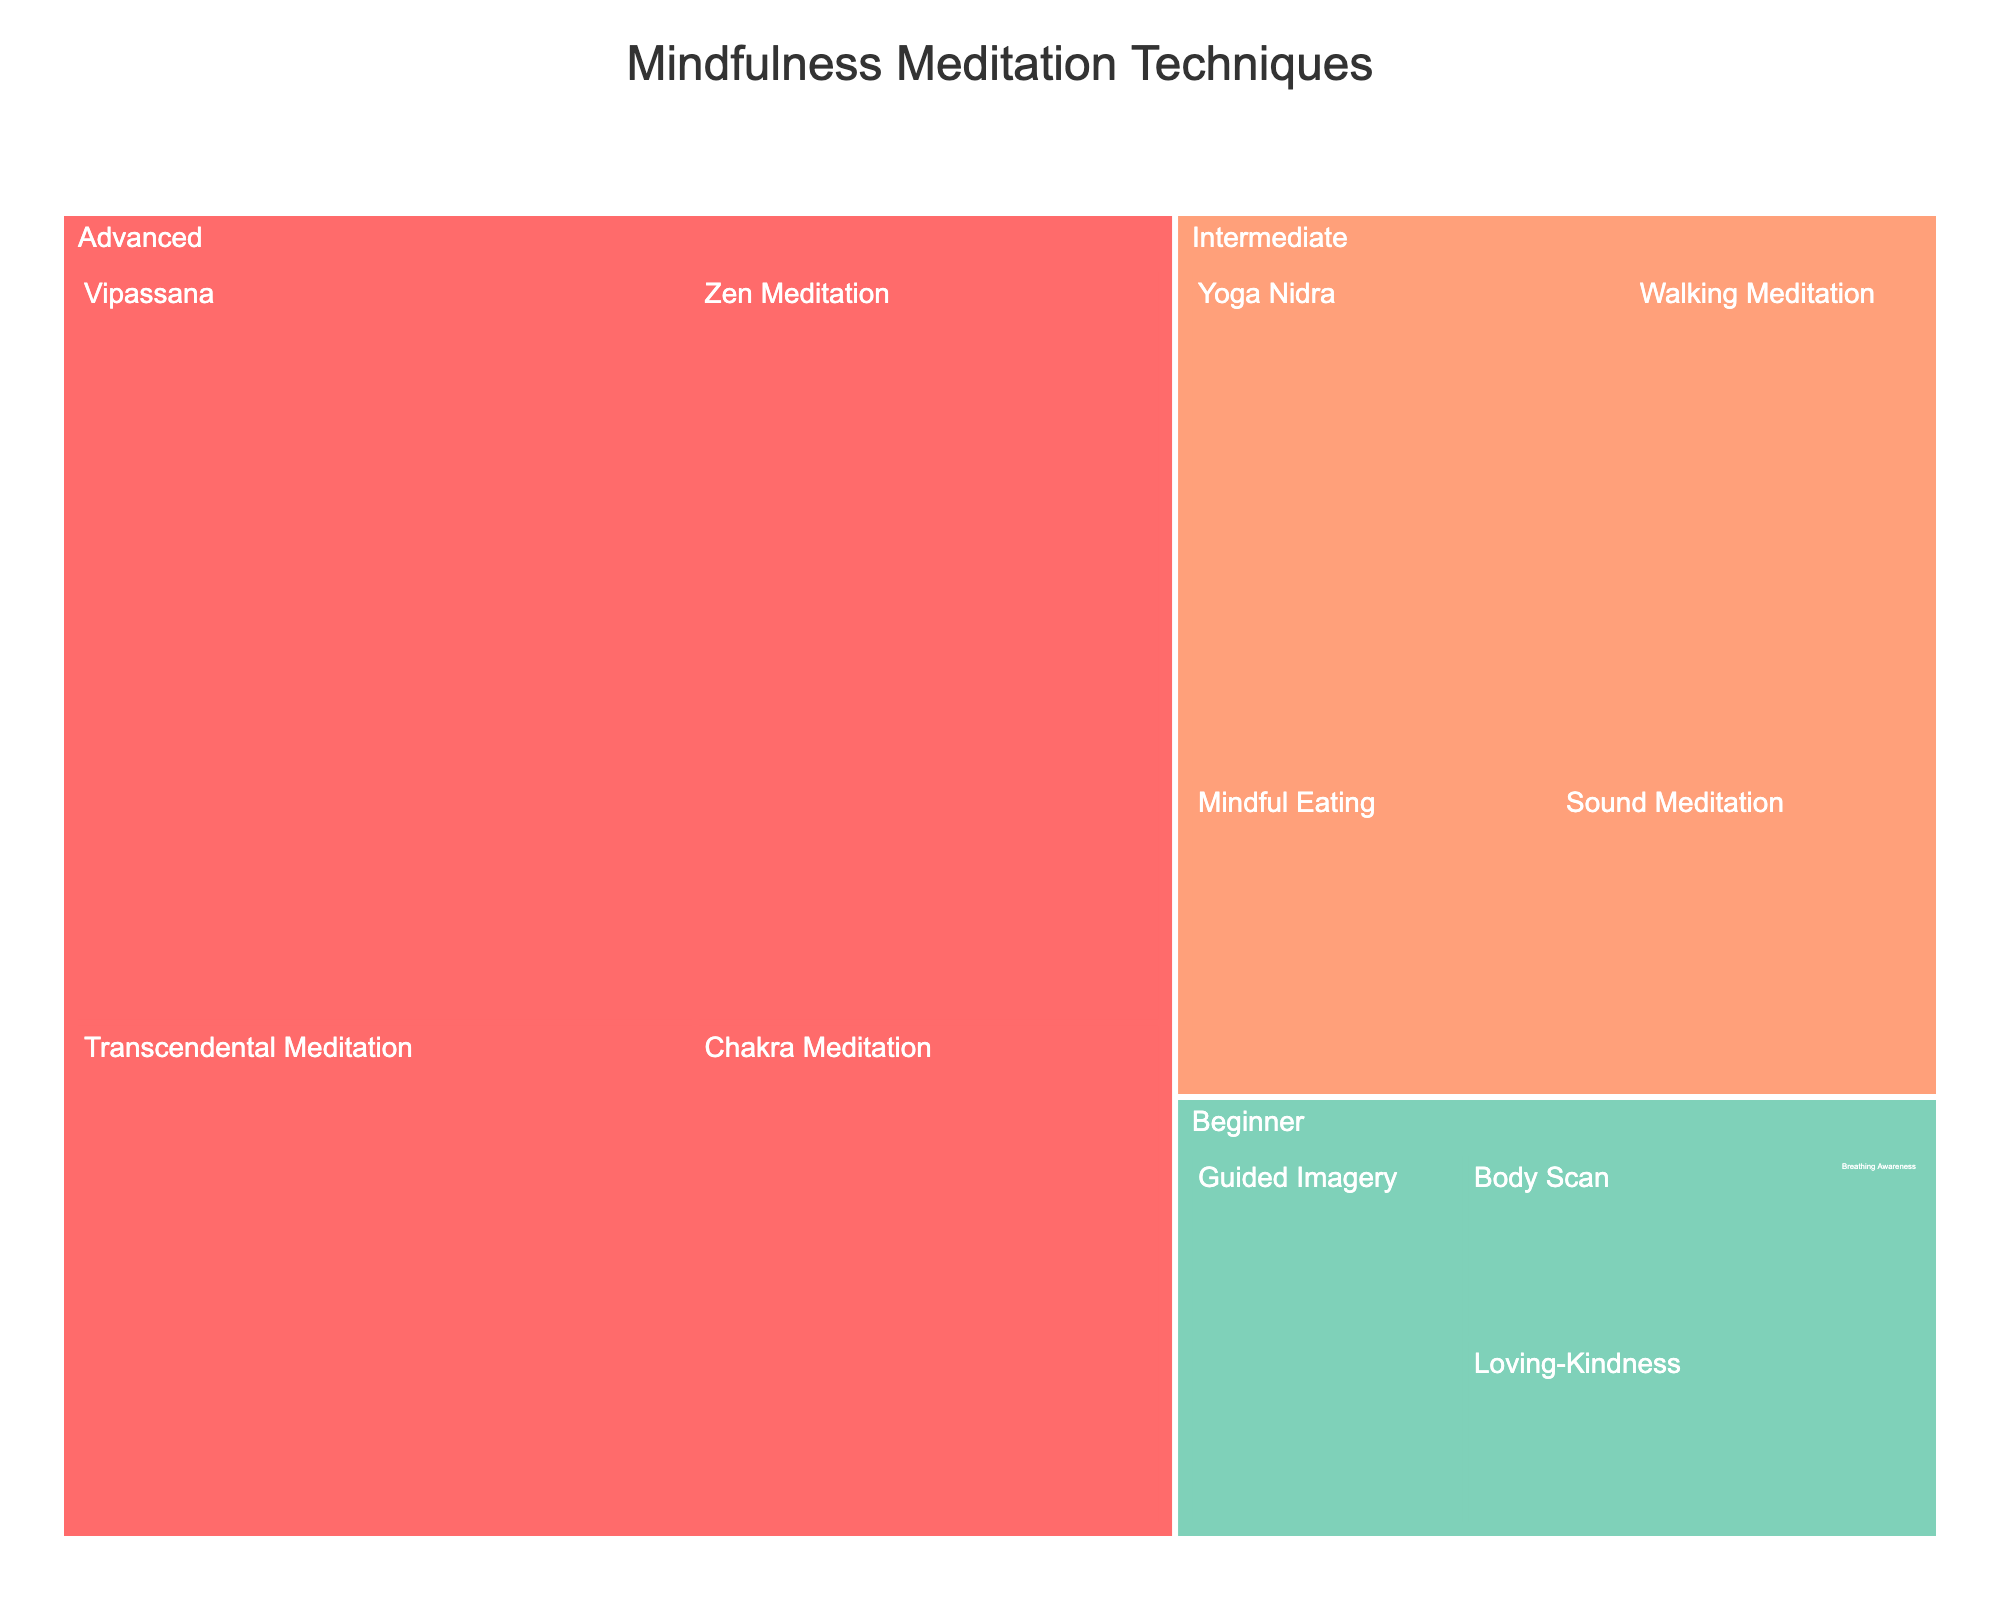What is the title of the figure? The title is displayed at the top of the treemap.
Answer: Mindfulness Meditation Techniques Which technique is the easiest and has the least time commitment? Look for techniques labeled 'Easy' with the smallest time value.
Answer: Breathing Awareness What is the total time commitment for beginner techniques? Sum the time values of all beginner techniques. 10 + 5 + 10 + 15 = 40
Answer: 40 minutes Which advanced technique requires the most time? Identify the advanced technique with the highest time value.
Answer: Vipassana How does the time commitment of “Intermediate” category compare to the “Beginner” category? Sum the time values of both categories and compare. Intermediate: 20 + 15 + 15 + 30 = 80; Beginner: 10 + 5 + 10 + 15 = 40
Answer: Intermediate techniques require more time What's the average time commitment for advanced techniques? Sum the time values and divide by the number of advanced techniques. (60 + 45 + 40 + 30) / 4 = 43.75
Answer: 43.75 minutes Which technique in the “Intermediate” category has the shortest time commitment? Look for the intermediate technique with the smallest time value.
Answer: Mindful Eating and Sound Yoga Nidra Which category has the highest overall time commitment? Sum the time values of each category and compare. Advanced: 60 + 45 + 40 + 30 = 175; Intermediate: 20 + 15 + 15 + 30 = 80; Beginner: 10 + 5 + 10 + 15 = 40
Answer: Advanced How does the difficulty level affect time commitment in these mindfulness techniques? Compare the time ranges across difficulty levels. Beginner techniques generally take 5-15 minutes, Intermediate take 15-30 minutes, and Advanced take 30-60 minutes.
Answer: Higher difficulty, more time Which beginner technique requires the most time? Identify the beginner technique with the highest time value.
Answer: Guided Imagery 